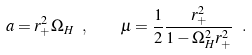<formula> <loc_0><loc_0><loc_500><loc_500>a = r _ { + } ^ { 2 } \Omega _ { H } \ , \quad \mu = \frac { 1 } { 2 } \frac { r _ { + } ^ { 2 } } { 1 - \Omega _ { H } ^ { 2 } r _ { + } ^ { 2 } } \ .</formula> 